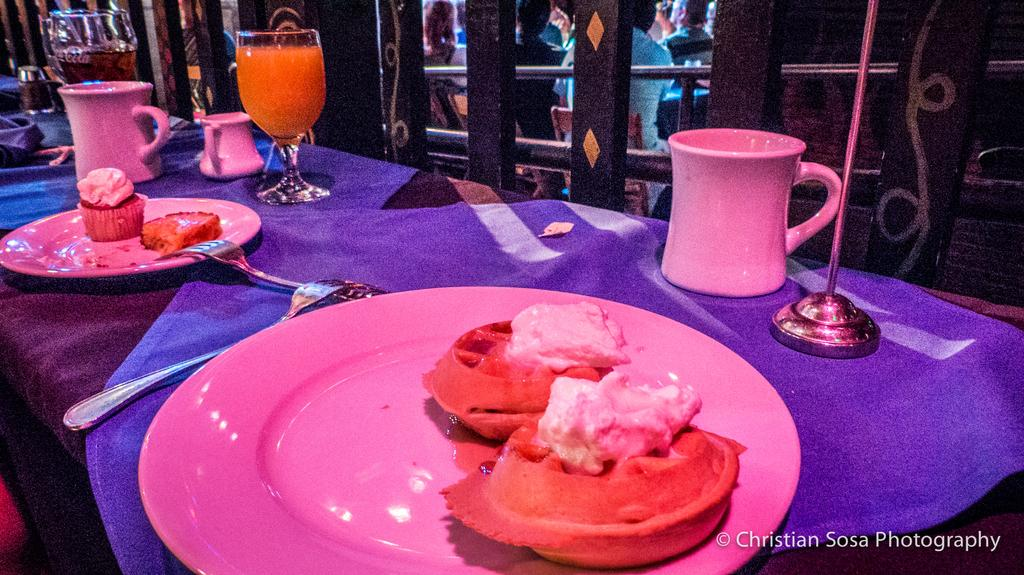What type of furniture is present in the image? There are tables in the image. What can be found on the tables? There are glasses, cups, and plates on the tables. What is on the plates? There is food on the plates. What utensils are visible in the image? There are forks visible in the image. Can you describe the people in the background of the image? There are people sitting on chairs in the background of the image. What type of tank can be seen in the image? There is no tank present in the image. How many wrens are sitting on the plates in the image? There are no wrens present in the image; it features food on the plates. 